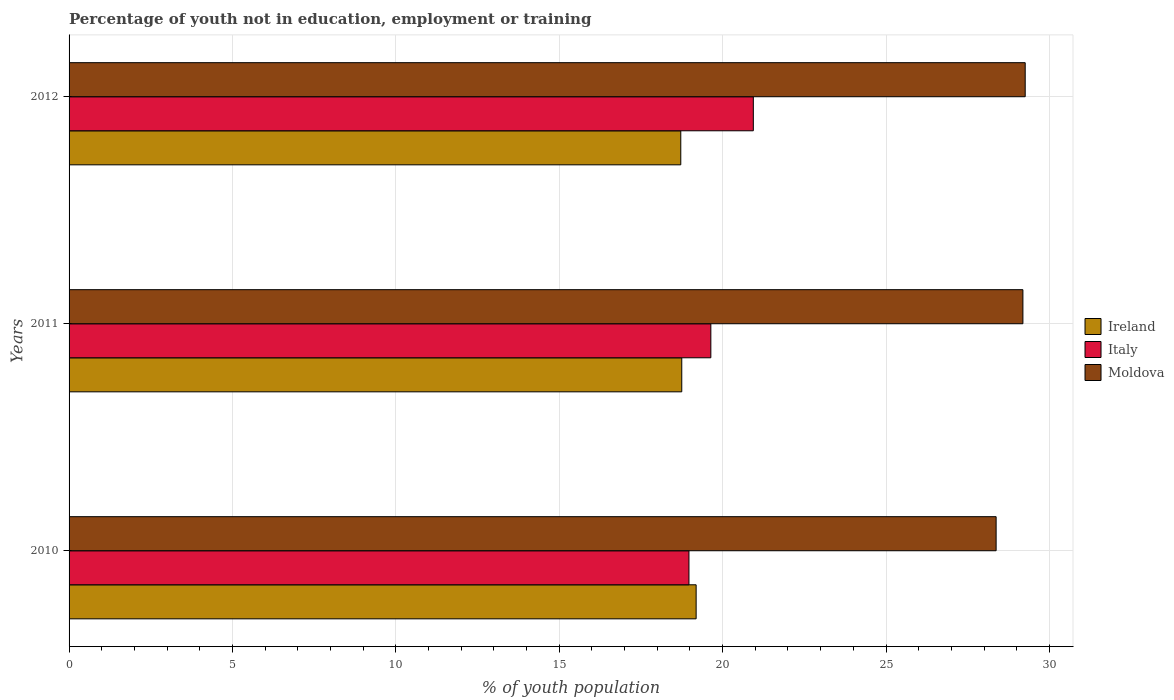How many different coloured bars are there?
Offer a very short reply. 3. How many groups of bars are there?
Your response must be concise. 3. In how many cases, is the number of bars for a given year not equal to the number of legend labels?
Offer a very short reply. 0. What is the percentage of unemployed youth population in in Ireland in 2010?
Give a very brief answer. 19.19. Across all years, what is the maximum percentage of unemployed youth population in in Ireland?
Give a very brief answer. 19.19. Across all years, what is the minimum percentage of unemployed youth population in in Moldova?
Provide a succinct answer. 28.37. In which year was the percentage of unemployed youth population in in Italy maximum?
Keep it short and to the point. 2012. What is the total percentage of unemployed youth population in in Moldova in the graph?
Provide a succinct answer. 86.82. What is the difference between the percentage of unemployed youth population in in Ireland in 2011 and that in 2012?
Offer a terse response. 0.03. What is the difference between the percentage of unemployed youth population in in Ireland in 2010 and the percentage of unemployed youth population in in Italy in 2012?
Your answer should be very brief. -1.75. What is the average percentage of unemployed youth population in in Italy per year?
Keep it short and to the point. 19.85. In the year 2012, what is the difference between the percentage of unemployed youth population in in Moldova and percentage of unemployed youth population in in Ireland?
Provide a succinct answer. 10.54. In how many years, is the percentage of unemployed youth population in in Ireland greater than 8 %?
Offer a terse response. 3. What is the ratio of the percentage of unemployed youth population in in Italy in 2011 to that in 2012?
Your answer should be very brief. 0.94. Is the percentage of unemployed youth population in in Moldova in 2010 less than that in 2011?
Offer a terse response. Yes. What is the difference between the highest and the second highest percentage of unemployed youth population in in Italy?
Your answer should be compact. 1.3. What is the difference between the highest and the lowest percentage of unemployed youth population in in Italy?
Provide a succinct answer. 1.97. What does the 3rd bar from the top in 2012 represents?
Your answer should be very brief. Ireland. What does the 3rd bar from the bottom in 2011 represents?
Provide a short and direct response. Moldova. Are all the bars in the graph horizontal?
Give a very brief answer. Yes. How many years are there in the graph?
Your answer should be very brief. 3. Does the graph contain any zero values?
Offer a terse response. No. How are the legend labels stacked?
Give a very brief answer. Vertical. What is the title of the graph?
Your answer should be very brief. Percentage of youth not in education, employment or training. Does "South Asia" appear as one of the legend labels in the graph?
Your answer should be compact. No. What is the label or title of the X-axis?
Make the answer very short. % of youth population. What is the label or title of the Y-axis?
Ensure brevity in your answer.  Years. What is the % of youth population in Ireland in 2010?
Offer a very short reply. 19.19. What is the % of youth population of Italy in 2010?
Keep it short and to the point. 18.97. What is the % of youth population in Moldova in 2010?
Provide a succinct answer. 28.37. What is the % of youth population of Ireland in 2011?
Provide a short and direct response. 18.75. What is the % of youth population in Italy in 2011?
Provide a succinct answer. 19.64. What is the % of youth population of Moldova in 2011?
Ensure brevity in your answer.  29.19. What is the % of youth population in Ireland in 2012?
Provide a short and direct response. 18.72. What is the % of youth population of Italy in 2012?
Provide a succinct answer. 20.94. What is the % of youth population of Moldova in 2012?
Provide a short and direct response. 29.26. Across all years, what is the maximum % of youth population of Ireland?
Keep it short and to the point. 19.19. Across all years, what is the maximum % of youth population of Italy?
Your answer should be compact. 20.94. Across all years, what is the maximum % of youth population in Moldova?
Offer a terse response. 29.26. Across all years, what is the minimum % of youth population in Ireland?
Keep it short and to the point. 18.72. Across all years, what is the minimum % of youth population of Italy?
Ensure brevity in your answer.  18.97. Across all years, what is the minimum % of youth population of Moldova?
Ensure brevity in your answer.  28.37. What is the total % of youth population in Ireland in the graph?
Give a very brief answer. 56.66. What is the total % of youth population in Italy in the graph?
Provide a short and direct response. 59.55. What is the total % of youth population in Moldova in the graph?
Offer a terse response. 86.82. What is the difference between the % of youth population in Ireland in 2010 and that in 2011?
Offer a terse response. 0.44. What is the difference between the % of youth population of Italy in 2010 and that in 2011?
Your answer should be compact. -0.67. What is the difference between the % of youth population in Moldova in 2010 and that in 2011?
Your answer should be compact. -0.82. What is the difference between the % of youth population of Ireland in 2010 and that in 2012?
Offer a terse response. 0.47. What is the difference between the % of youth population of Italy in 2010 and that in 2012?
Give a very brief answer. -1.97. What is the difference between the % of youth population of Moldova in 2010 and that in 2012?
Provide a short and direct response. -0.89. What is the difference between the % of youth population in Ireland in 2011 and that in 2012?
Offer a terse response. 0.03. What is the difference between the % of youth population of Italy in 2011 and that in 2012?
Your answer should be very brief. -1.3. What is the difference between the % of youth population in Moldova in 2011 and that in 2012?
Your answer should be very brief. -0.07. What is the difference between the % of youth population in Ireland in 2010 and the % of youth population in Italy in 2011?
Your answer should be very brief. -0.45. What is the difference between the % of youth population of Italy in 2010 and the % of youth population of Moldova in 2011?
Provide a succinct answer. -10.22. What is the difference between the % of youth population of Ireland in 2010 and the % of youth population of Italy in 2012?
Offer a very short reply. -1.75. What is the difference between the % of youth population in Ireland in 2010 and the % of youth population in Moldova in 2012?
Keep it short and to the point. -10.07. What is the difference between the % of youth population in Italy in 2010 and the % of youth population in Moldova in 2012?
Make the answer very short. -10.29. What is the difference between the % of youth population in Ireland in 2011 and the % of youth population in Italy in 2012?
Provide a succinct answer. -2.19. What is the difference between the % of youth population in Ireland in 2011 and the % of youth population in Moldova in 2012?
Ensure brevity in your answer.  -10.51. What is the difference between the % of youth population in Italy in 2011 and the % of youth population in Moldova in 2012?
Offer a terse response. -9.62. What is the average % of youth population in Ireland per year?
Offer a terse response. 18.89. What is the average % of youth population of Italy per year?
Your answer should be compact. 19.85. What is the average % of youth population of Moldova per year?
Keep it short and to the point. 28.94. In the year 2010, what is the difference between the % of youth population in Ireland and % of youth population in Italy?
Your answer should be very brief. 0.22. In the year 2010, what is the difference between the % of youth population in Ireland and % of youth population in Moldova?
Offer a very short reply. -9.18. In the year 2011, what is the difference between the % of youth population in Ireland and % of youth population in Italy?
Ensure brevity in your answer.  -0.89. In the year 2011, what is the difference between the % of youth population of Ireland and % of youth population of Moldova?
Offer a very short reply. -10.44. In the year 2011, what is the difference between the % of youth population of Italy and % of youth population of Moldova?
Provide a succinct answer. -9.55. In the year 2012, what is the difference between the % of youth population of Ireland and % of youth population of Italy?
Ensure brevity in your answer.  -2.22. In the year 2012, what is the difference between the % of youth population of Ireland and % of youth population of Moldova?
Provide a succinct answer. -10.54. In the year 2012, what is the difference between the % of youth population in Italy and % of youth population in Moldova?
Make the answer very short. -8.32. What is the ratio of the % of youth population of Ireland in 2010 to that in 2011?
Give a very brief answer. 1.02. What is the ratio of the % of youth population of Italy in 2010 to that in 2011?
Provide a short and direct response. 0.97. What is the ratio of the % of youth population in Moldova in 2010 to that in 2011?
Your answer should be very brief. 0.97. What is the ratio of the % of youth population of Ireland in 2010 to that in 2012?
Ensure brevity in your answer.  1.03. What is the ratio of the % of youth population in Italy in 2010 to that in 2012?
Make the answer very short. 0.91. What is the ratio of the % of youth population of Moldova in 2010 to that in 2012?
Give a very brief answer. 0.97. What is the ratio of the % of youth population in Ireland in 2011 to that in 2012?
Provide a succinct answer. 1. What is the ratio of the % of youth population of Italy in 2011 to that in 2012?
Your answer should be very brief. 0.94. What is the ratio of the % of youth population in Moldova in 2011 to that in 2012?
Provide a succinct answer. 1. What is the difference between the highest and the second highest % of youth population in Ireland?
Provide a short and direct response. 0.44. What is the difference between the highest and the second highest % of youth population in Moldova?
Offer a very short reply. 0.07. What is the difference between the highest and the lowest % of youth population of Ireland?
Offer a very short reply. 0.47. What is the difference between the highest and the lowest % of youth population in Italy?
Your answer should be very brief. 1.97. What is the difference between the highest and the lowest % of youth population in Moldova?
Keep it short and to the point. 0.89. 